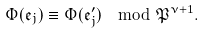Convert formula to latex. <formula><loc_0><loc_0><loc_500><loc_500>\Phi ( \mathfrak { e } _ { j } ) \equiv \Phi ( \mathfrak { e } _ { j } ^ { \prime } ) \mod \mathfrak { P } ^ { \nu + 1 } .</formula> 